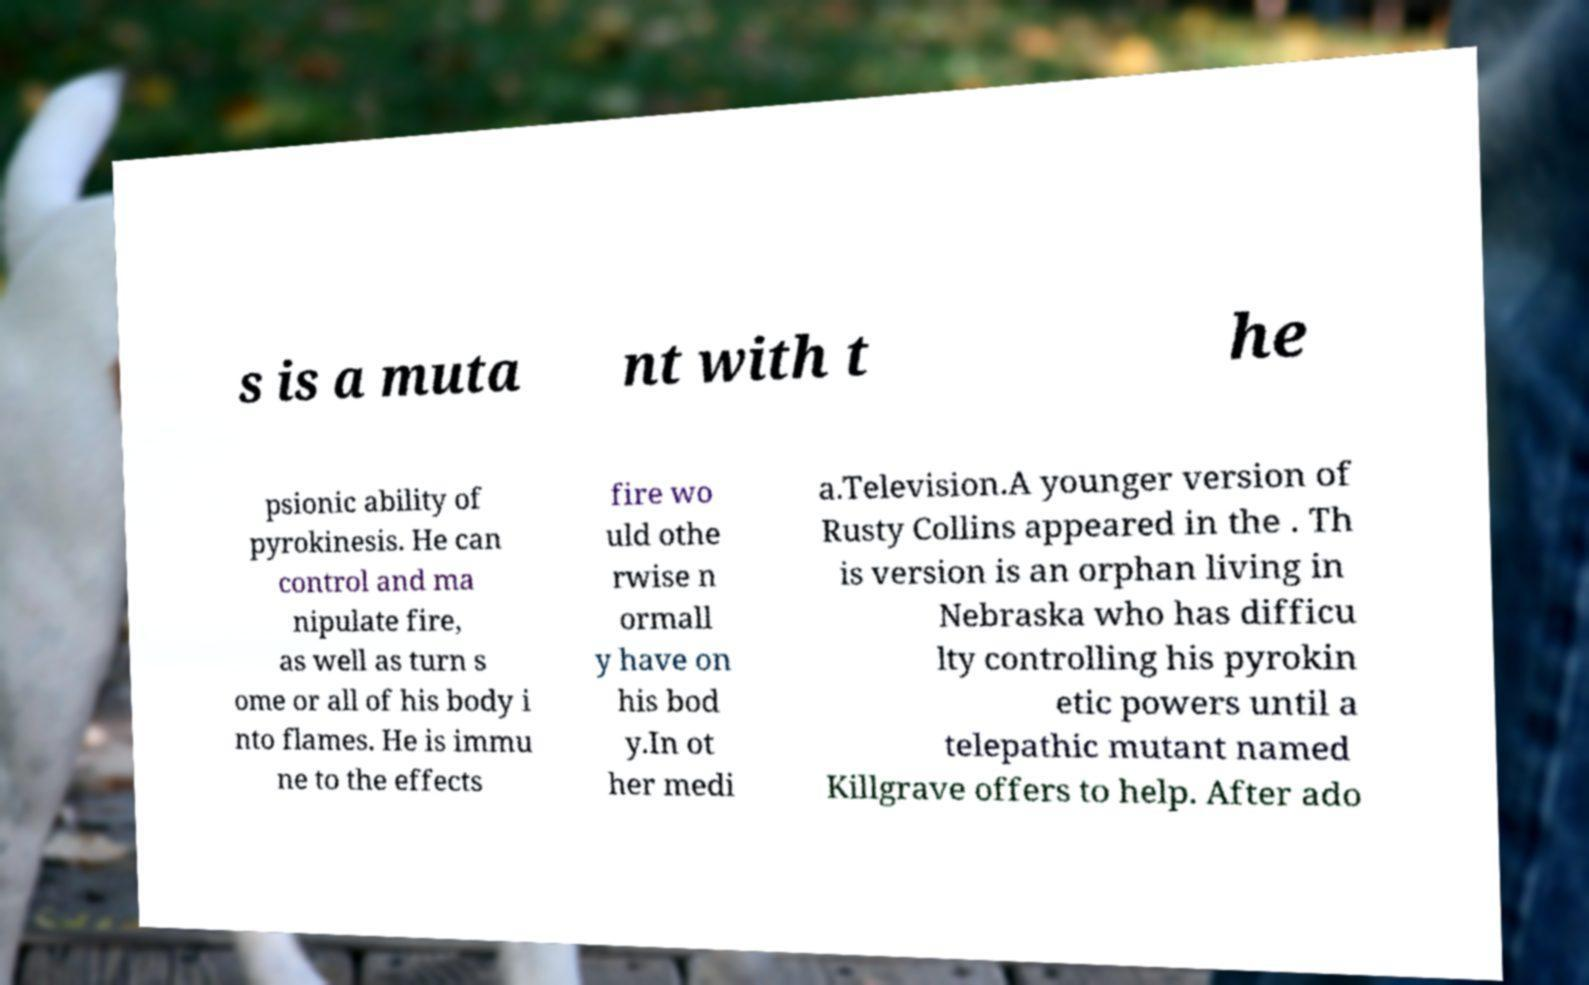Please identify and transcribe the text found in this image. s is a muta nt with t he psionic ability of pyrokinesis. He can control and ma nipulate fire, as well as turn s ome or all of his body i nto flames. He is immu ne to the effects fire wo uld othe rwise n ormall y have on his bod y.In ot her medi a.Television.A younger version of Rusty Collins appeared in the . Th is version is an orphan living in Nebraska who has difficu lty controlling his pyrokin etic powers until a telepathic mutant named Killgrave offers to help. After ado 